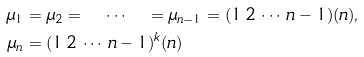<formula> <loc_0><loc_0><loc_500><loc_500>\mu _ { 1 } & = \mu _ { 2 } = \quad \cdots \quad = \mu _ { n - 1 } = ( 1 \, 2 \, \cdots \, n - 1 ) ( n ) , \\ \mu _ { n } & = ( 1 \, 2 \, \cdots \, n - 1 ) ^ { k } ( n )</formula> 